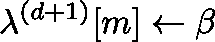Convert formula to latex. <formula><loc_0><loc_0><loc_500><loc_500>\lambda ^ { ( d + 1 ) } [ m ] \gets \beta</formula> 